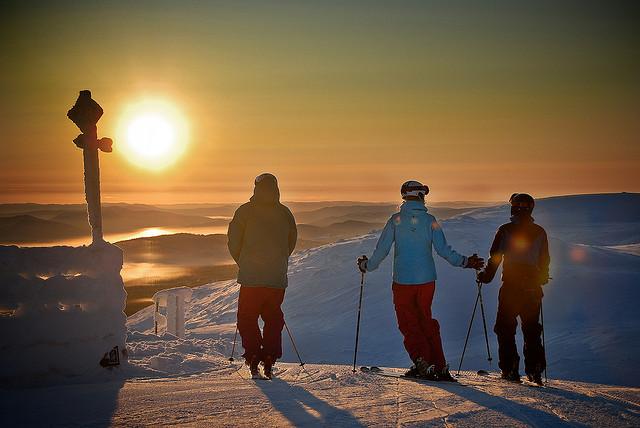What is in the background?
Give a very brief answer. Sun. Are the people going to ski?
Short answer required. Yes. Where is this?
Answer briefly. Mountain. Where are the people standing?
Concise answer only. Snow. Is the sun shining?
Keep it brief. Yes. 